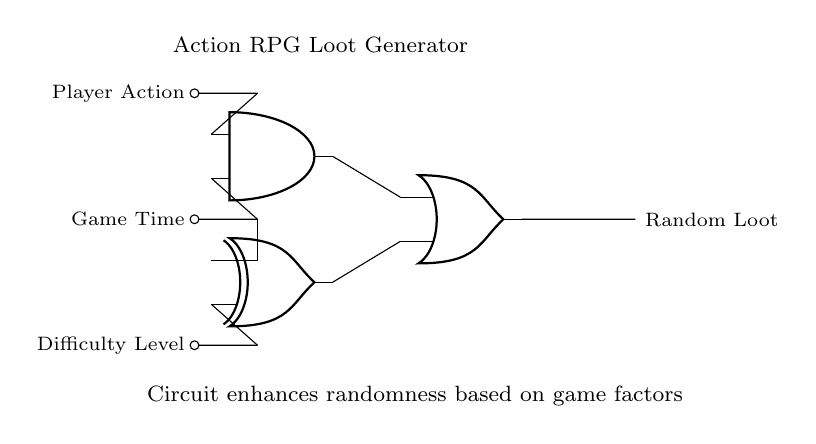What are the input signals to the circuit? The input signals are Player Action, Game Time, and Difficulty Level, which are represented as inputs to the logic gates in the circuit.
Answer: Player Action, Game Time, Difficulty Level What type of logic gate is at the top of the diagram? The top gate is an AND gate, indicated by its symbol in the circuit architecture. It combines multiple inputs to produce a single output.
Answer: AND How many logic gates are used in the circuit? The circuit consists of three logic gates: one AND gate, one XOR gate, and one OR gate, each serving a specific function in processing the inputs.
Answer: Three What is the output of the circuit? The output of the circuit is labeled as Random Loot, which signifies the final result produced by the logic gates based on the combined inputs.
Answer: Random Loot What is the role of the XOR gate in this circuit? The XOR gate processes two of the input signals and provides an output that represents the exclusive nature of the inputs, contributing to the overall randomness of the output.
Answer: Randomness Which input signal connects to both the AND gate and the XOR gate? The Game Time input connects to both the AND gate as one of its inputs and to the XOR gate, demonstrating its dual contribution to the circuit's logic.
Answer: Game Time How does the output relate to the AND and XOR gates? The Random Loot output is influenced by the results of both the AND gate and the XOR gate; the AND gate ensures that certain conditions must be met, while the XOR gate adds an element of variability based on the input signals.
Answer: Combined influence 